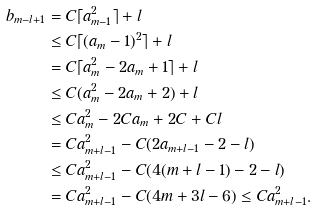Convert formula to latex. <formula><loc_0><loc_0><loc_500><loc_500>b _ { m - l + 1 } & = C \lceil a _ { m - 1 } ^ { 2 } \rceil + l \\ & \leq C \lceil ( a _ { m } - 1 ) ^ { 2 } \rceil + l \\ & = C \lceil a _ { m } ^ { 2 } - 2 a _ { m } + 1 \rceil + l \\ & \leq C ( a _ { m } ^ { 2 } - 2 a _ { m } + 2 ) + l \\ & \leq C a _ { m } ^ { 2 } - 2 C a _ { m } + 2 C + C l \\ & = C a _ { m + l - 1 } ^ { 2 } - C ( 2 a _ { m + l - 1 } - 2 - l ) \\ & \leq C a _ { m + l - 1 } ^ { 2 } - C ( 4 ( m + l - 1 ) - 2 - l ) \\ & = C a _ { m + l - 1 } ^ { 2 } - C ( 4 m + 3 l - 6 ) \leq C a _ { m + l - 1 } ^ { 2 } .</formula> 